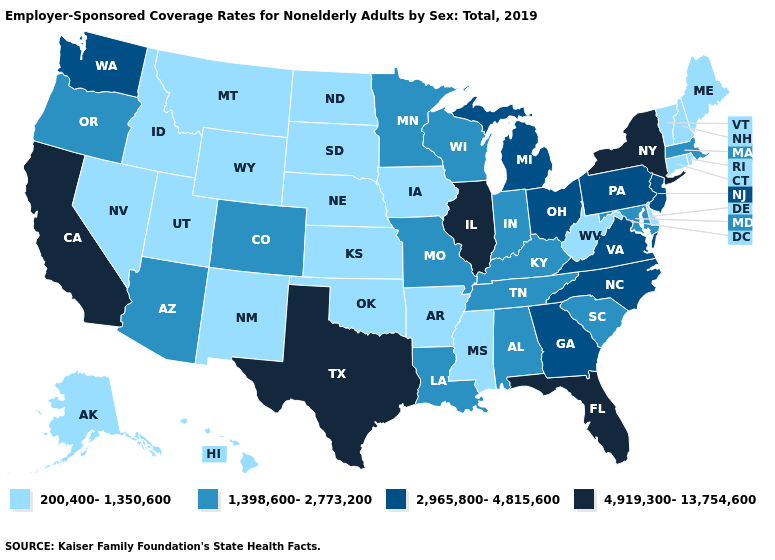What is the value of Rhode Island?
Concise answer only. 200,400-1,350,600. How many symbols are there in the legend?
Write a very short answer. 4. Which states hav the highest value in the South?
Short answer required. Florida, Texas. Name the states that have a value in the range 200,400-1,350,600?
Concise answer only. Alaska, Arkansas, Connecticut, Delaware, Hawaii, Idaho, Iowa, Kansas, Maine, Mississippi, Montana, Nebraska, Nevada, New Hampshire, New Mexico, North Dakota, Oklahoma, Rhode Island, South Dakota, Utah, Vermont, West Virginia, Wyoming. What is the value of Idaho?
Answer briefly. 200,400-1,350,600. Does Georgia have the lowest value in the South?
Quick response, please. No. What is the lowest value in states that border Texas?
Be succinct. 200,400-1,350,600. What is the lowest value in the USA?
Write a very short answer. 200,400-1,350,600. Name the states that have a value in the range 4,919,300-13,754,600?
Be succinct. California, Florida, Illinois, New York, Texas. Name the states that have a value in the range 1,398,600-2,773,200?
Write a very short answer. Alabama, Arizona, Colorado, Indiana, Kentucky, Louisiana, Maryland, Massachusetts, Minnesota, Missouri, Oregon, South Carolina, Tennessee, Wisconsin. What is the lowest value in the MidWest?
Give a very brief answer. 200,400-1,350,600. Which states have the highest value in the USA?
Short answer required. California, Florida, Illinois, New York, Texas. What is the value of New Hampshire?
Keep it brief. 200,400-1,350,600. Does the first symbol in the legend represent the smallest category?
Write a very short answer. Yes. Does California have the lowest value in the West?
Give a very brief answer. No. 